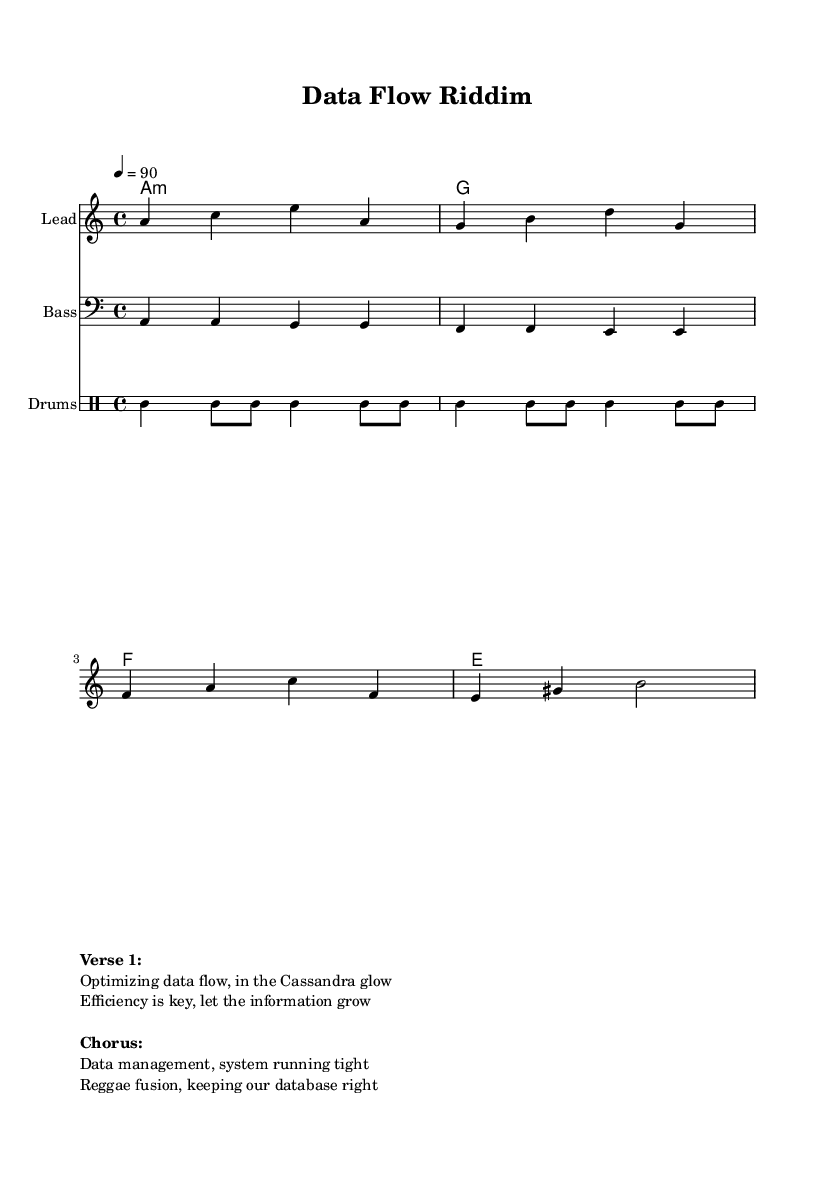What is the key signature of this music? The key signature is A minor, which has no sharps or flats.
Answer: A minor What is the time signature of the piece? The time signature is indicated as 4/4, which means there are 4 beats in each measure and a quarter note gets one beat.
Answer: 4/4 What is the tempo marking for this music? The tempo marking is 4 equals 90, meaning there are 90 quarter note beats per minute.
Answer: 90 How many measures are present in the melody section? The melody section has 4 measures, which can be counted by observing the grouping of notes separated by bar lines.
Answer: 4 What type of fusion is represented in this track? The track represents reggae fusion, which combines elements of reggae with other genres, as indicated by the genre description in the markup section.
Answer: Reggae fusion What does the chorus emphasize about data management? The chorus emphasizes that data management is crucial for keeping the system running efficiently and effectively.
Answer: System running tight What instruments are involved in the arrangement? The arrangement includes a Lead instrument (melody), a Bass instrument, and Drums, as indicated by the staff names specified in the score.
Answer: Lead, Bass, Drums 